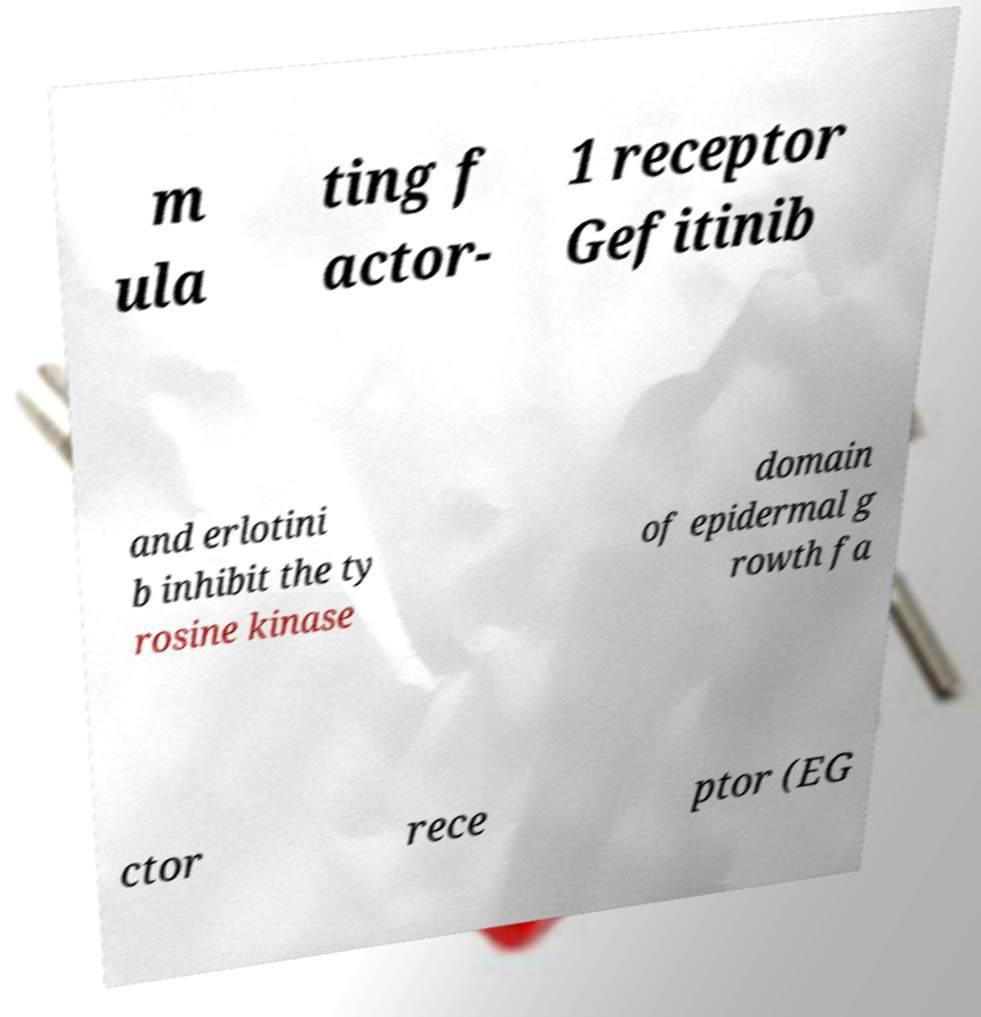I need the written content from this picture converted into text. Can you do that? m ula ting f actor- 1 receptor Gefitinib and erlotini b inhibit the ty rosine kinase domain of epidermal g rowth fa ctor rece ptor (EG 